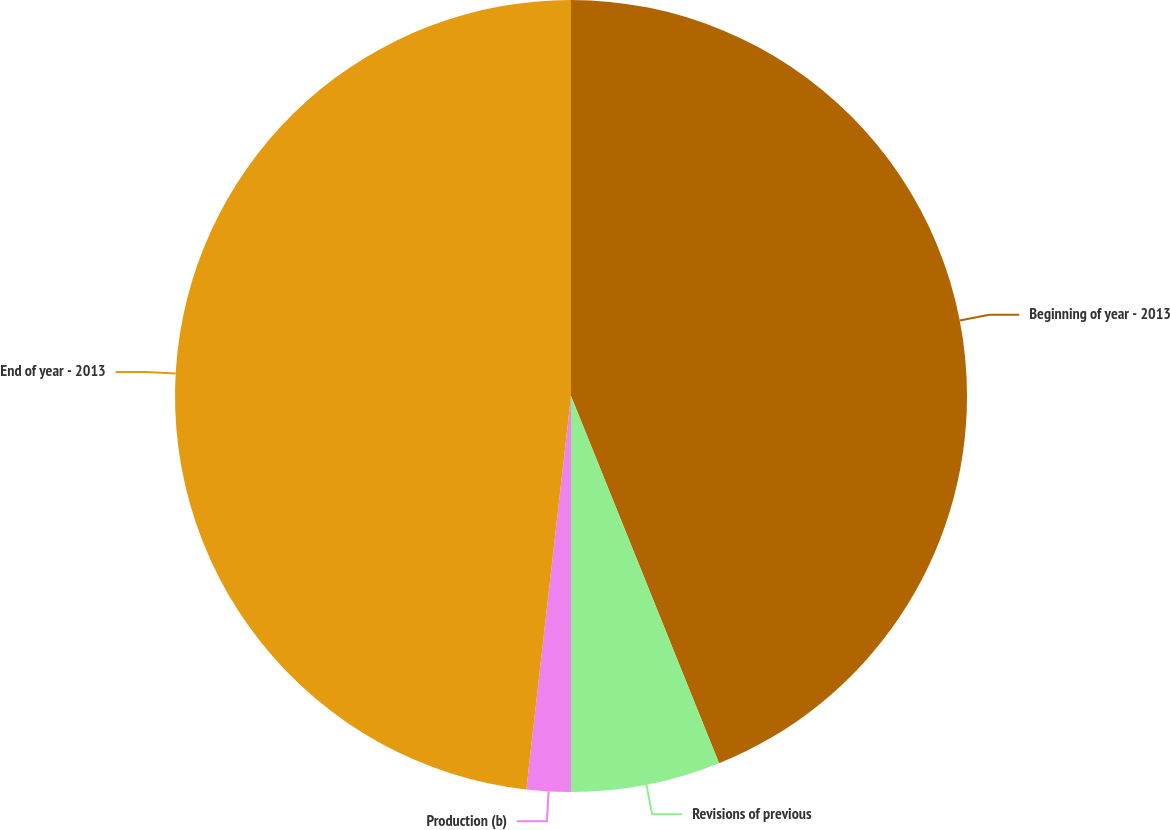Convert chart. <chart><loc_0><loc_0><loc_500><loc_500><pie_chart><fcel>Beginning of year - 2013<fcel>Revisions of previous<fcel>Production (b)<fcel>End of year - 2013<nl><fcel>43.9%<fcel>6.1%<fcel>1.8%<fcel>48.2%<nl></chart> 